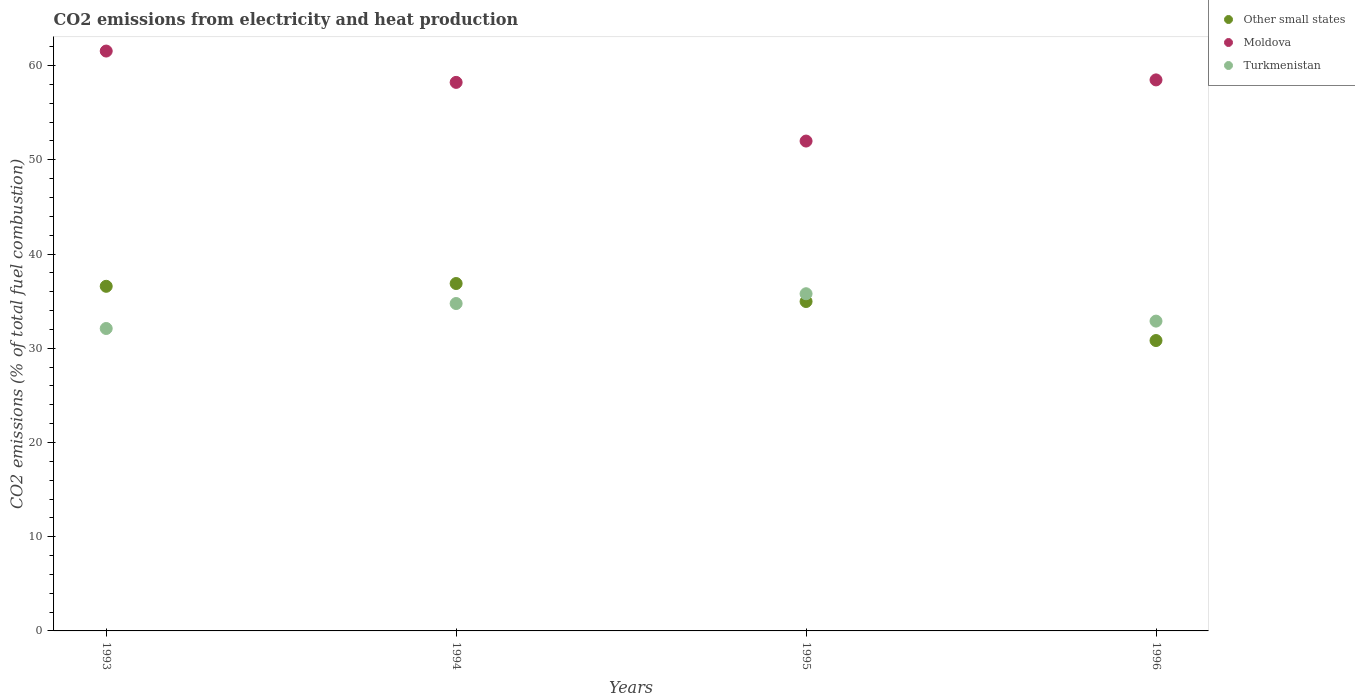How many different coloured dotlines are there?
Make the answer very short. 3. What is the amount of CO2 emitted in Moldova in 1995?
Your answer should be compact. 51.99. Across all years, what is the maximum amount of CO2 emitted in Moldova?
Keep it short and to the point. 61.54. Across all years, what is the minimum amount of CO2 emitted in Turkmenistan?
Provide a succinct answer. 32.1. In which year was the amount of CO2 emitted in Turkmenistan maximum?
Offer a very short reply. 1995. In which year was the amount of CO2 emitted in Other small states minimum?
Your response must be concise. 1996. What is the total amount of CO2 emitted in Moldova in the graph?
Provide a succinct answer. 230.23. What is the difference between the amount of CO2 emitted in Turkmenistan in 1994 and that in 1996?
Keep it short and to the point. 1.87. What is the difference between the amount of CO2 emitted in Moldova in 1994 and the amount of CO2 emitted in Other small states in 1995?
Your response must be concise. 23.26. What is the average amount of CO2 emitted in Other small states per year?
Offer a terse response. 34.81. In the year 1996, what is the difference between the amount of CO2 emitted in Other small states and amount of CO2 emitted in Turkmenistan?
Give a very brief answer. -2.06. What is the ratio of the amount of CO2 emitted in Moldova in 1995 to that in 1996?
Ensure brevity in your answer.  0.89. Is the amount of CO2 emitted in Other small states in 1993 less than that in 1994?
Keep it short and to the point. Yes. What is the difference between the highest and the second highest amount of CO2 emitted in Moldova?
Provide a short and direct response. 3.06. What is the difference between the highest and the lowest amount of CO2 emitted in Turkmenistan?
Provide a short and direct response. 3.69. In how many years, is the amount of CO2 emitted in Moldova greater than the average amount of CO2 emitted in Moldova taken over all years?
Provide a succinct answer. 3. Is it the case that in every year, the sum of the amount of CO2 emitted in Other small states and amount of CO2 emitted in Turkmenistan  is greater than the amount of CO2 emitted in Moldova?
Ensure brevity in your answer.  Yes. How many dotlines are there?
Keep it short and to the point. 3. What is the difference between two consecutive major ticks on the Y-axis?
Give a very brief answer. 10. Are the values on the major ticks of Y-axis written in scientific E-notation?
Give a very brief answer. No. How are the legend labels stacked?
Give a very brief answer. Vertical. What is the title of the graph?
Keep it short and to the point. CO2 emissions from electricity and heat production. Does "New Caledonia" appear as one of the legend labels in the graph?
Offer a very short reply. No. What is the label or title of the X-axis?
Provide a succinct answer. Years. What is the label or title of the Y-axis?
Keep it short and to the point. CO2 emissions (% of total fuel combustion). What is the CO2 emissions (% of total fuel combustion) in Other small states in 1993?
Keep it short and to the point. 36.58. What is the CO2 emissions (% of total fuel combustion) of Moldova in 1993?
Provide a succinct answer. 61.54. What is the CO2 emissions (% of total fuel combustion) of Turkmenistan in 1993?
Your answer should be very brief. 32.1. What is the CO2 emissions (% of total fuel combustion) in Other small states in 1994?
Offer a terse response. 36.87. What is the CO2 emissions (% of total fuel combustion) of Moldova in 1994?
Make the answer very short. 58.22. What is the CO2 emissions (% of total fuel combustion) in Turkmenistan in 1994?
Your response must be concise. 34.75. What is the CO2 emissions (% of total fuel combustion) of Other small states in 1995?
Provide a succinct answer. 34.96. What is the CO2 emissions (% of total fuel combustion) in Moldova in 1995?
Your answer should be compact. 51.99. What is the CO2 emissions (% of total fuel combustion) of Turkmenistan in 1995?
Offer a terse response. 35.79. What is the CO2 emissions (% of total fuel combustion) in Other small states in 1996?
Offer a terse response. 30.82. What is the CO2 emissions (% of total fuel combustion) of Moldova in 1996?
Ensure brevity in your answer.  58.48. What is the CO2 emissions (% of total fuel combustion) of Turkmenistan in 1996?
Provide a short and direct response. 32.88. Across all years, what is the maximum CO2 emissions (% of total fuel combustion) in Other small states?
Provide a succinct answer. 36.87. Across all years, what is the maximum CO2 emissions (% of total fuel combustion) of Moldova?
Offer a very short reply. 61.54. Across all years, what is the maximum CO2 emissions (% of total fuel combustion) of Turkmenistan?
Offer a very short reply. 35.79. Across all years, what is the minimum CO2 emissions (% of total fuel combustion) of Other small states?
Your answer should be very brief. 30.82. Across all years, what is the minimum CO2 emissions (% of total fuel combustion) of Moldova?
Keep it short and to the point. 51.99. Across all years, what is the minimum CO2 emissions (% of total fuel combustion) of Turkmenistan?
Offer a very short reply. 32.1. What is the total CO2 emissions (% of total fuel combustion) in Other small states in the graph?
Ensure brevity in your answer.  139.23. What is the total CO2 emissions (% of total fuel combustion) in Moldova in the graph?
Ensure brevity in your answer.  230.23. What is the total CO2 emissions (% of total fuel combustion) of Turkmenistan in the graph?
Offer a very short reply. 135.51. What is the difference between the CO2 emissions (% of total fuel combustion) of Other small states in 1993 and that in 1994?
Your answer should be very brief. -0.3. What is the difference between the CO2 emissions (% of total fuel combustion) of Moldova in 1993 and that in 1994?
Make the answer very short. 3.33. What is the difference between the CO2 emissions (% of total fuel combustion) of Turkmenistan in 1993 and that in 1994?
Keep it short and to the point. -2.65. What is the difference between the CO2 emissions (% of total fuel combustion) of Other small states in 1993 and that in 1995?
Offer a very short reply. 1.61. What is the difference between the CO2 emissions (% of total fuel combustion) in Moldova in 1993 and that in 1995?
Give a very brief answer. 9.55. What is the difference between the CO2 emissions (% of total fuel combustion) in Turkmenistan in 1993 and that in 1995?
Give a very brief answer. -3.69. What is the difference between the CO2 emissions (% of total fuel combustion) in Other small states in 1993 and that in 1996?
Provide a succinct answer. 5.76. What is the difference between the CO2 emissions (% of total fuel combustion) in Moldova in 1993 and that in 1996?
Provide a succinct answer. 3.06. What is the difference between the CO2 emissions (% of total fuel combustion) in Turkmenistan in 1993 and that in 1996?
Make the answer very short. -0.78. What is the difference between the CO2 emissions (% of total fuel combustion) of Other small states in 1994 and that in 1995?
Offer a very short reply. 1.91. What is the difference between the CO2 emissions (% of total fuel combustion) of Moldova in 1994 and that in 1995?
Your answer should be very brief. 6.23. What is the difference between the CO2 emissions (% of total fuel combustion) in Turkmenistan in 1994 and that in 1995?
Your answer should be very brief. -1.04. What is the difference between the CO2 emissions (% of total fuel combustion) of Other small states in 1994 and that in 1996?
Make the answer very short. 6.05. What is the difference between the CO2 emissions (% of total fuel combustion) of Moldova in 1994 and that in 1996?
Make the answer very short. -0.26. What is the difference between the CO2 emissions (% of total fuel combustion) in Turkmenistan in 1994 and that in 1996?
Offer a very short reply. 1.87. What is the difference between the CO2 emissions (% of total fuel combustion) in Other small states in 1995 and that in 1996?
Give a very brief answer. 4.14. What is the difference between the CO2 emissions (% of total fuel combustion) of Moldova in 1995 and that in 1996?
Keep it short and to the point. -6.49. What is the difference between the CO2 emissions (% of total fuel combustion) of Turkmenistan in 1995 and that in 1996?
Your answer should be compact. 2.9. What is the difference between the CO2 emissions (% of total fuel combustion) of Other small states in 1993 and the CO2 emissions (% of total fuel combustion) of Moldova in 1994?
Your response must be concise. -21.64. What is the difference between the CO2 emissions (% of total fuel combustion) in Other small states in 1993 and the CO2 emissions (% of total fuel combustion) in Turkmenistan in 1994?
Make the answer very short. 1.83. What is the difference between the CO2 emissions (% of total fuel combustion) in Moldova in 1993 and the CO2 emissions (% of total fuel combustion) in Turkmenistan in 1994?
Your answer should be compact. 26.8. What is the difference between the CO2 emissions (% of total fuel combustion) in Other small states in 1993 and the CO2 emissions (% of total fuel combustion) in Moldova in 1995?
Offer a terse response. -15.41. What is the difference between the CO2 emissions (% of total fuel combustion) of Other small states in 1993 and the CO2 emissions (% of total fuel combustion) of Turkmenistan in 1995?
Give a very brief answer. 0.79. What is the difference between the CO2 emissions (% of total fuel combustion) of Moldova in 1993 and the CO2 emissions (% of total fuel combustion) of Turkmenistan in 1995?
Ensure brevity in your answer.  25.76. What is the difference between the CO2 emissions (% of total fuel combustion) of Other small states in 1993 and the CO2 emissions (% of total fuel combustion) of Moldova in 1996?
Your response must be concise. -21.91. What is the difference between the CO2 emissions (% of total fuel combustion) in Other small states in 1993 and the CO2 emissions (% of total fuel combustion) in Turkmenistan in 1996?
Give a very brief answer. 3.69. What is the difference between the CO2 emissions (% of total fuel combustion) in Moldova in 1993 and the CO2 emissions (% of total fuel combustion) in Turkmenistan in 1996?
Offer a very short reply. 28.66. What is the difference between the CO2 emissions (% of total fuel combustion) in Other small states in 1994 and the CO2 emissions (% of total fuel combustion) in Moldova in 1995?
Offer a terse response. -15.12. What is the difference between the CO2 emissions (% of total fuel combustion) in Other small states in 1994 and the CO2 emissions (% of total fuel combustion) in Turkmenistan in 1995?
Provide a succinct answer. 1.09. What is the difference between the CO2 emissions (% of total fuel combustion) in Moldova in 1994 and the CO2 emissions (% of total fuel combustion) in Turkmenistan in 1995?
Offer a very short reply. 22.43. What is the difference between the CO2 emissions (% of total fuel combustion) in Other small states in 1994 and the CO2 emissions (% of total fuel combustion) in Moldova in 1996?
Ensure brevity in your answer.  -21.61. What is the difference between the CO2 emissions (% of total fuel combustion) in Other small states in 1994 and the CO2 emissions (% of total fuel combustion) in Turkmenistan in 1996?
Your answer should be compact. 3.99. What is the difference between the CO2 emissions (% of total fuel combustion) of Moldova in 1994 and the CO2 emissions (% of total fuel combustion) of Turkmenistan in 1996?
Your response must be concise. 25.34. What is the difference between the CO2 emissions (% of total fuel combustion) of Other small states in 1995 and the CO2 emissions (% of total fuel combustion) of Moldova in 1996?
Make the answer very short. -23.52. What is the difference between the CO2 emissions (% of total fuel combustion) of Other small states in 1995 and the CO2 emissions (% of total fuel combustion) of Turkmenistan in 1996?
Your answer should be compact. 2.08. What is the difference between the CO2 emissions (% of total fuel combustion) in Moldova in 1995 and the CO2 emissions (% of total fuel combustion) in Turkmenistan in 1996?
Provide a succinct answer. 19.11. What is the average CO2 emissions (% of total fuel combustion) in Other small states per year?
Ensure brevity in your answer.  34.81. What is the average CO2 emissions (% of total fuel combustion) of Moldova per year?
Your answer should be compact. 57.56. What is the average CO2 emissions (% of total fuel combustion) in Turkmenistan per year?
Your answer should be compact. 33.88. In the year 1993, what is the difference between the CO2 emissions (% of total fuel combustion) in Other small states and CO2 emissions (% of total fuel combustion) in Moldova?
Provide a short and direct response. -24.97. In the year 1993, what is the difference between the CO2 emissions (% of total fuel combustion) of Other small states and CO2 emissions (% of total fuel combustion) of Turkmenistan?
Your answer should be compact. 4.48. In the year 1993, what is the difference between the CO2 emissions (% of total fuel combustion) of Moldova and CO2 emissions (% of total fuel combustion) of Turkmenistan?
Your answer should be compact. 29.45. In the year 1994, what is the difference between the CO2 emissions (% of total fuel combustion) of Other small states and CO2 emissions (% of total fuel combustion) of Moldova?
Your response must be concise. -21.35. In the year 1994, what is the difference between the CO2 emissions (% of total fuel combustion) in Other small states and CO2 emissions (% of total fuel combustion) in Turkmenistan?
Provide a short and direct response. 2.12. In the year 1994, what is the difference between the CO2 emissions (% of total fuel combustion) of Moldova and CO2 emissions (% of total fuel combustion) of Turkmenistan?
Provide a short and direct response. 23.47. In the year 1995, what is the difference between the CO2 emissions (% of total fuel combustion) in Other small states and CO2 emissions (% of total fuel combustion) in Moldova?
Give a very brief answer. -17.03. In the year 1995, what is the difference between the CO2 emissions (% of total fuel combustion) of Other small states and CO2 emissions (% of total fuel combustion) of Turkmenistan?
Offer a very short reply. -0.82. In the year 1995, what is the difference between the CO2 emissions (% of total fuel combustion) of Moldova and CO2 emissions (% of total fuel combustion) of Turkmenistan?
Keep it short and to the point. 16.2. In the year 1996, what is the difference between the CO2 emissions (% of total fuel combustion) in Other small states and CO2 emissions (% of total fuel combustion) in Moldova?
Offer a very short reply. -27.66. In the year 1996, what is the difference between the CO2 emissions (% of total fuel combustion) of Other small states and CO2 emissions (% of total fuel combustion) of Turkmenistan?
Provide a short and direct response. -2.06. In the year 1996, what is the difference between the CO2 emissions (% of total fuel combustion) of Moldova and CO2 emissions (% of total fuel combustion) of Turkmenistan?
Offer a terse response. 25.6. What is the ratio of the CO2 emissions (% of total fuel combustion) in Moldova in 1993 to that in 1994?
Offer a terse response. 1.06. What is the ratio of the CO2 emissions (% of total fuel combustion) of Turkmenistan in 1993 to that in 1994?
Provide a short and direct response. 0.92. What is the ratio of the CO2 emissions (% of total fuel combustion) of Other small states in 1993 to that in 1995?
Give a very brief answer. 1.05. What is the ratio of the CO2 emissions (% of total fuel combustion) of Moldova in 1993 to that in 1995?
Ensure brevity in your answer.  1.18. What is the ratio of the CO2 emissions (% of total fuel combustion) in Turkmenistan in 1993 to that in 1995?
Provide a short and direct response. 0.9. What is the ratio of the CO2 emissions (% of total fuel combustion) in Other small states in 1993 to that in 1996?
Ensure brevity in your answer.  1.19. What is the ratio of the CO2 emissions (% of total fuel combustion) of Moldova in 1993 to that in 1996?
Your answer should be compact. 1.05. What is the ratio of the CO2 emissions (% of total fuel combustion) of Turkmenistan in 1993 to that in 1996?
Offer a terse response. 0.98. What is the ratio of the CO2 emissions (% of total fuel combustion) of Other small states in 1994 to that in 1995?
Offer a terse response. 1.05. What is the ratio of the CO2 emissions (% of total fuel combustion) of Moldova in 1994 to that in 1995?
Your answer should be compact. 1.12. What is the ratio of the CO2 emissions (% of total fuel combustion) of Turkmenistan in 1994 to that in 1995?
Your response must be concise. 0.97. What is the ratio of the CO2 emissions (% of total fuel combustion) of Other small states in 1994 to that in 1996?
Offer a terse response. 1.2. What is the ratio of the CO2 emissions (% of total fuel combustion) in Moldova in 1994 to that in 1996?
Provide a succinct answer. 1. What is the ratio of the CO2 emissions (% of total fuel combustion) of Turkmenistan in 1994 to that in 1996?
Provide a succinct answer. 1.06. What is the ratio of the CO2 emissions (% of total fuel combustion) of Other small states in 1995 to that in 1996?
Your answer should be very brief. 1.13. What is the ratio of the CO2 emissions (% of total fuel combustion) in Moldova in 1995 to that in 1996?
Provide a short and direct response. 0.89. What is the ratio of the CO2 emissions (% of total fuel combustion) of Turkmenistan in 1995 to that in 1996?
Offer a very short reply. 1.09. What is the difference between the highest and the second highest CO2 emissions (% of total fuel combustion) of Other small states?
Make the answer very short. 0.3. What is the difference between the highest and the second highest CO2 emissions (% of total fuel combustion) of Moldova?
Offer a terse response. 3.06. What is the difference between the highest and the second highest CO2 emissions (% of total fuel combustion) in Turkmenistan?
Make the answer very short. 1.04. What is the difference between the highest and the lowest CO2 emissions (% of total fuel combustion) of Other small states?
Provide a succinct answer. 6.05. What is the difference between the highest and the lowest CO2 emissions (% of total fuel combustion) in Moldova?
Your answer should be compact. 9.55. What is the difference between the highest and the lowest CO2 emissions (% of total fuel combustion) of Turkmenistan?
Provide a short and direct response. 3.69. 